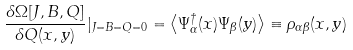Convert formula to latex. <formula><loc_0><loc_0><loc_500><loc_500>\frac { \delta \Omega [ J , B , Q ] } { \delta Q ( x , y ) } | _ { J = B = Q = 0 } = \left \langle \Psi _ { \alpha } ^ { \dagger } ( x ) \Psi _ { \beta } ( y ) \right \rangle \equiv \rho _ { \alpha \beta } ( x , y )</formula> 